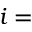<formula> <loc_0><loc_0><loc_500><loc_500>i =</formula> 